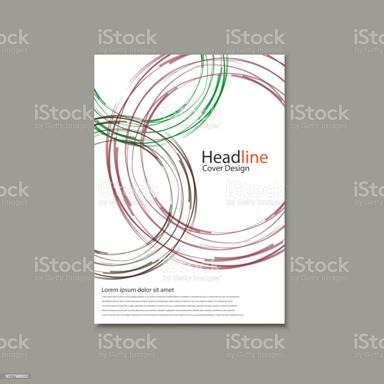Can you describe the overall design of the brochure in the image? The brochure in the image features a clean, modern design characterized by multiple abstract, circular lines looping around each other, rendered in shades of maroon and green. The headline 'Cover Design' is prominently displayed atop the design, followed by a sample lorem ipsum text block. The overall layout is simple yet striking, with a focus on the interplay of color and form to attract visual interest. 